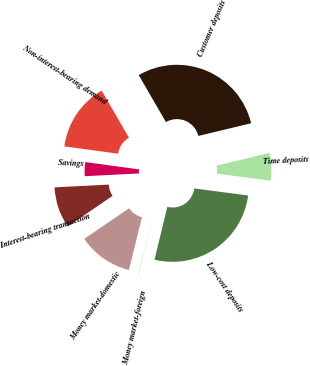<chart> <loc_0><loc_0><loc_500><loc_500><pie_chart><fcel>Non-interest-bearing demand<fcel>Savings<fcel>Interest-bearing transaction<fcel>Money market-domestic<fcel>Money market-foreign<fcel>Low-cost deposits<fcel>Time deposits<fcel>Customer deposits<nl><fcel>14.49%<fcel>2.96%<fcel>8.72%<fcel>11.61%<fcel>0.07%<fcel>26.71%<fcel>5.84%<fcel>29.6%<nl></chart> 